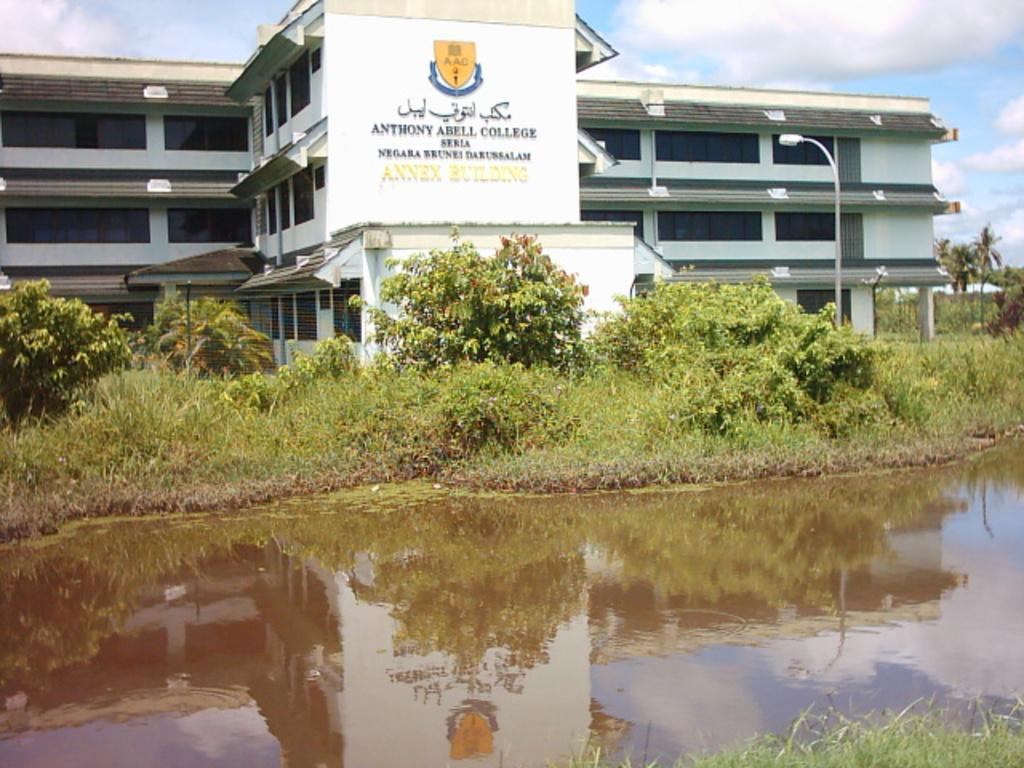<image>
Render a clear and concise summary of the photo. Anthony Abell College is seen behind a body of water. 